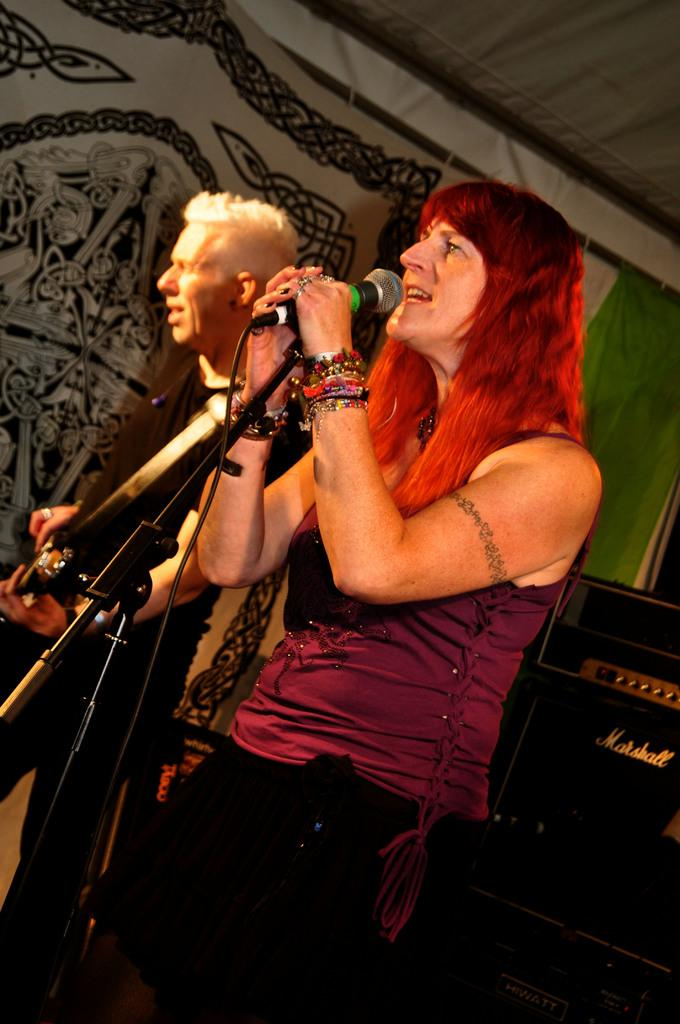How many people are in the image? There are two people in the image, a woman and a man. What are the woman and the man doing in the image? The woman is singing, and the man is playing a guitar. What can be seen on the left side of the image? There is a curtain on the left side of the image. What position are the woman and the man in? The woman and the man are both standing in the image. What type of comfort can be seen in the image? There is no specific type of comfort visible in the image. What is the man cooking in the image? There is no cooking activity depicted in the image; the man is playing a guitar. 